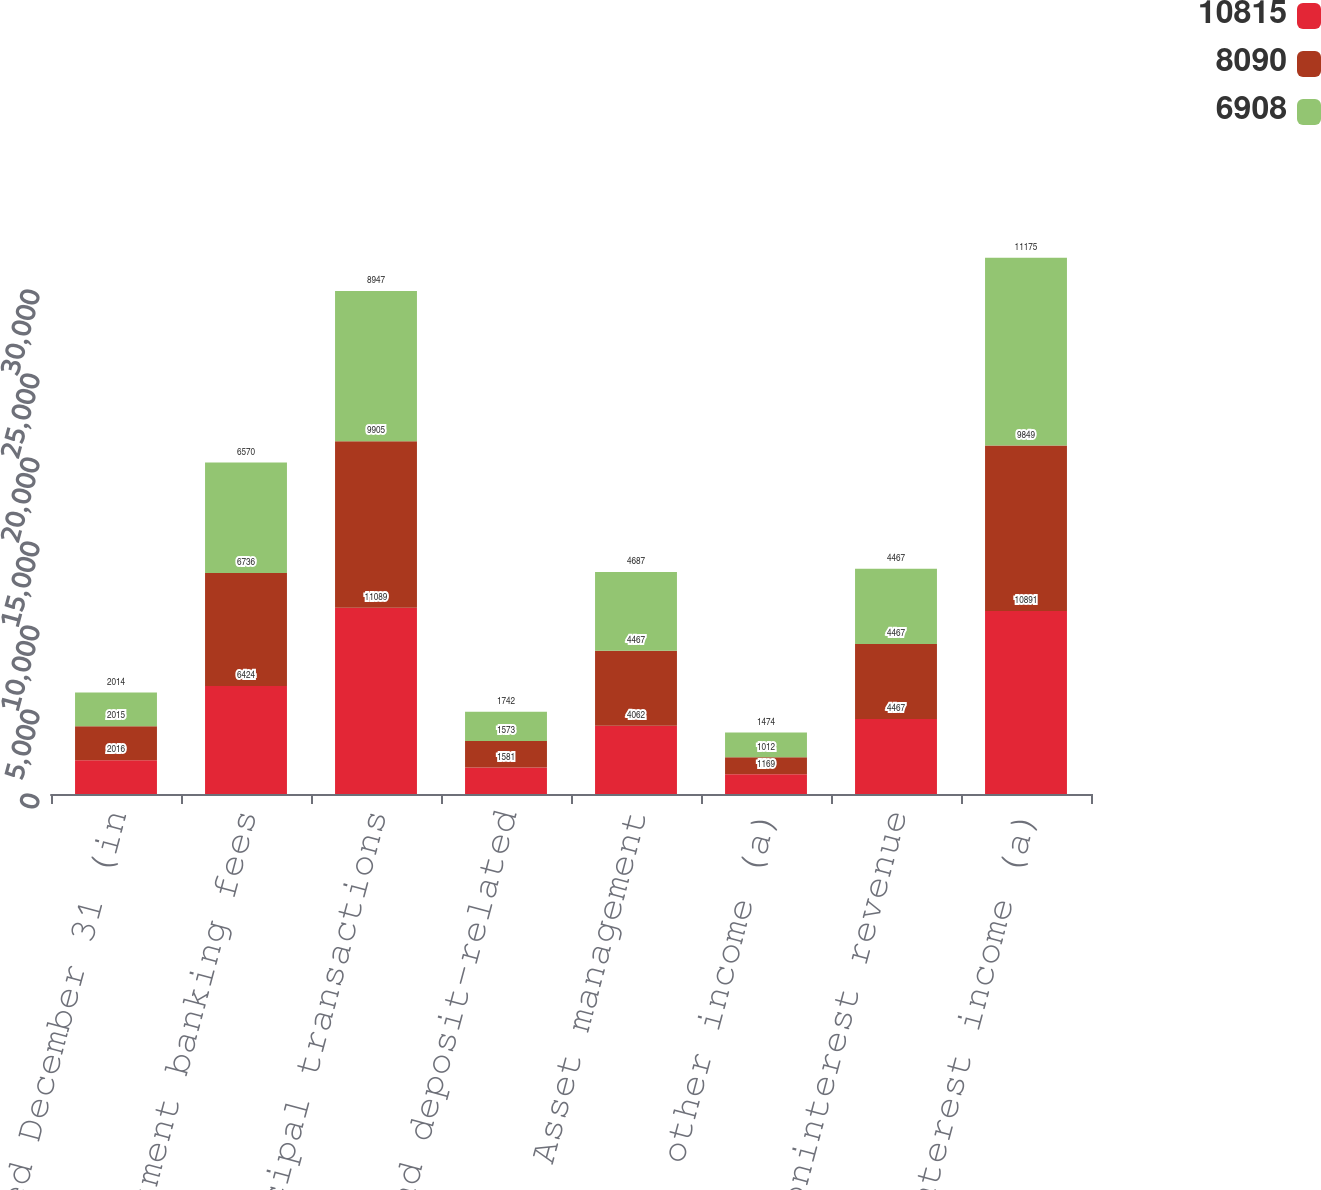Convert chart. <chart><loc_0><loc_0><loc_500><loc_500><stacked_bar_chart><ecel><fcel>Year ended December 31 (in<fcel>Investment banking fees<fcel>Principal transactions<fcel>Lending- and deposit-related<fcel>Asset management<fcel>All other income (a)<fcel>Noninterest revenue<fcel>Net interest income (a)<nl><fcel>10815<fcel>2016<fcel>6424<fcel>11089<fcel>1581<fcel>4062<fcel>1169<fcel>4467<fcel>10891<nl><fcel>8090<fcel>2015<fcel>6736<fcel>9905<fcel>1573<fcel>4467<fcel>1012<fcel>4467<fcel>9849<nl><fcel>6908<fcel>2014<fcel>6570<fcel>8947<fcel>1742<fcel>4687<fcel>1474<fcel>4467<fcel>11175<nl></chart> 